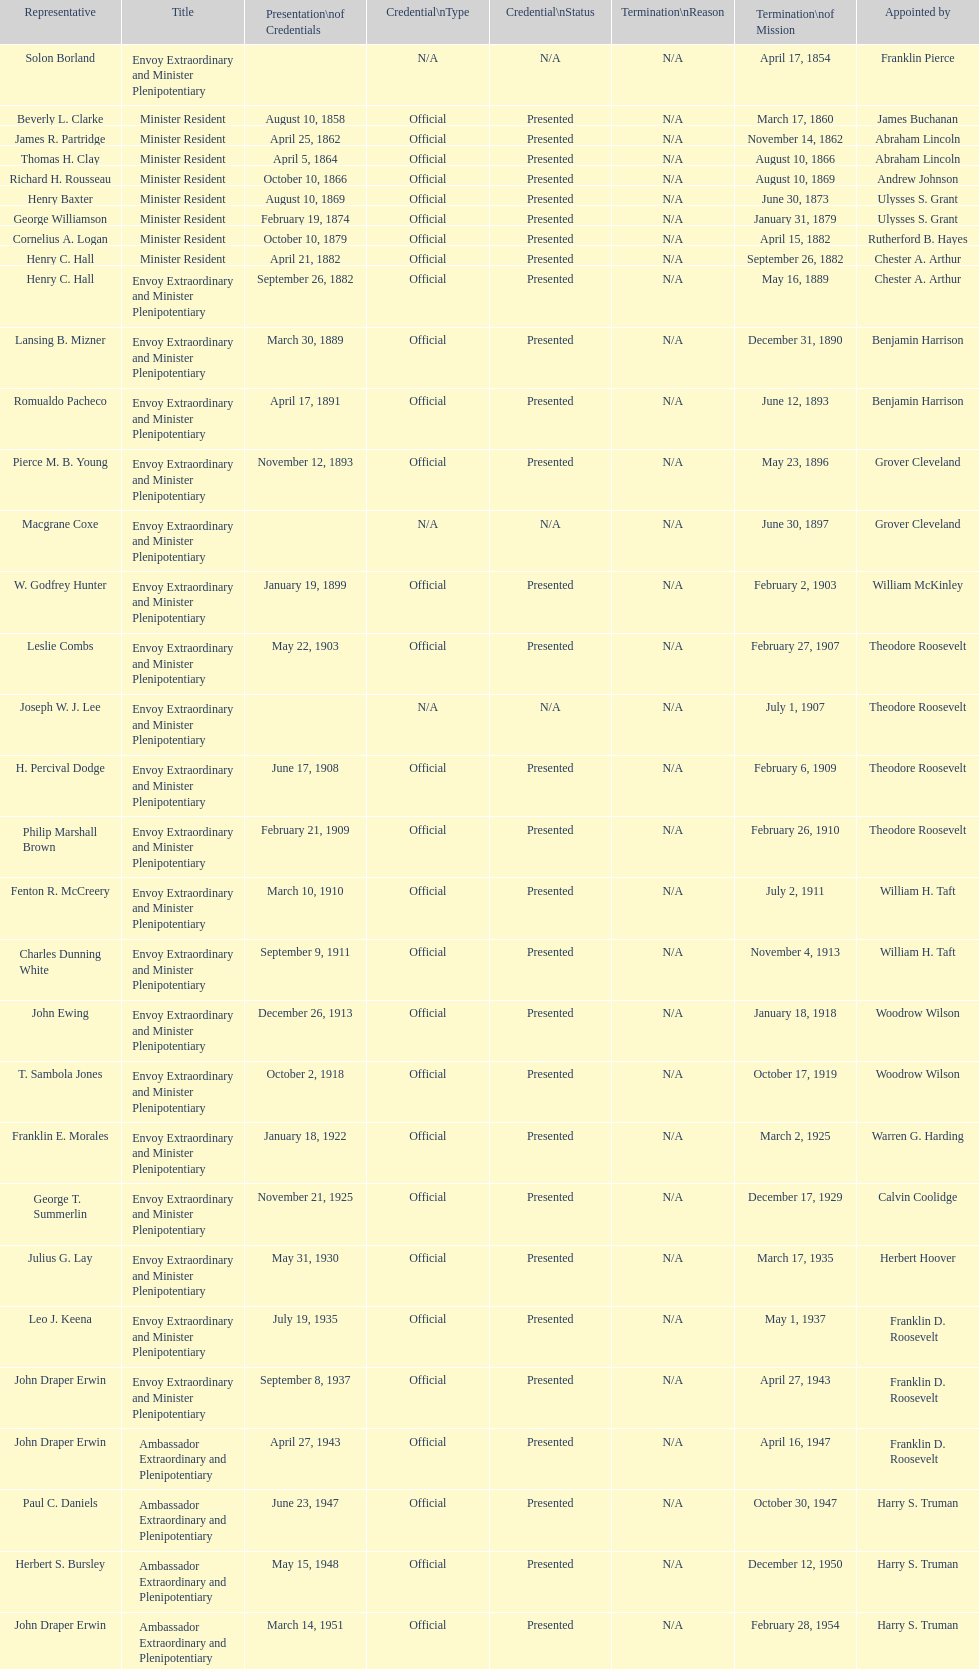Which envoy was the first appointed by woodrow wilson? John Ewing. 